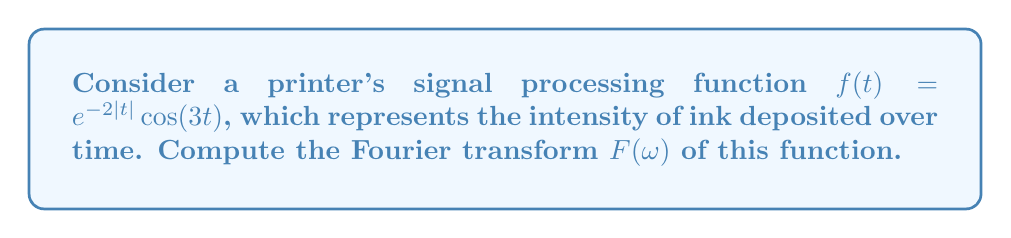Can you answer this question? Let's approach this step-by-step:

1) The Fourier transform is given by:
   $$F(\omega) = \int_{-\infty}^{\infty} f(t)e^{-i\omega t} dt$$

2) Substituting our function:
   $$F(\omega) = \int_{-\infty}^{\infty} e^{-2|t|}\cos(3t)e^{-i\omega t} dt$$

3) Using Euler's formula, $\cos(3t) = \frac{1}{2}(e^{3it} + e^{-3it})$:
   $$F(\omega) = \frac{1}{2}\int_{-\infty}^{\infty} e^{-2|t|}(e^{3it} + e^{-3it})e^{-i\omega t} dt$$

4) Splitting the integral:
   $$F(\omega) = \frac{1}{2}\int_{-\infty}^{\infty} e^{-2|t|}e^{i(3-\omega)t} dt + \frac{1}{2}\int_{-\infty}^{\infty} e^{-2|t|}e^{-i(3+\omega)t} dt$$

5) These integrals are of the form $\int_{-\infty}^{\infty} e^{-2|t|}e^{i\alpha t} dt$, which has a known solution:
   $$\int_{-\infty}^{\infty} e^{-2|t|}e^{i\alpha t} dt = \frac{4}{4+\alpha^2}$$

6) Applying this to our integrals:
   $$F(\omega) = \frac{1}{2} \cdot \frac{4}{4+(3-\omega)^2} + \frac{1}{2} \cdot \frac{4}{4+(3+\omega)^2}$$

7) Simplifying:
   $$F(\omega) = \frac{2}{4+(3-\omega)^2} + \frac{2}{4+(3+\omega)^2}$$

This is the Fourier transform of the printer's signal processing function.
Answer: $$F(\omega) = \frac{2}{4+(3-\omega)^2} + \frac{2}{4+(3+\omega)^2}$$ 